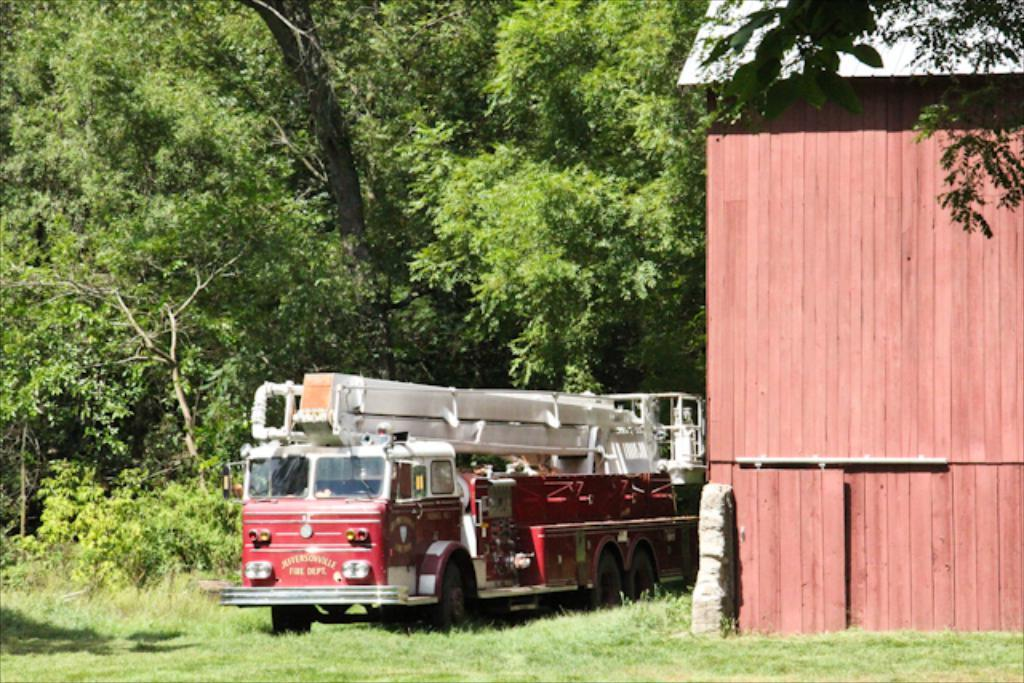What is the main subject of the image? The main subject of the image is a fire engine. What type of building can be seen in the image? There is a building with a wooden wall in the image. What is the ground covered with in the image? There is grass on the ground in the image. What can be seen in the background of the image? There are trees in the background of the image. What type of bottle is being used to surprise the fire engine in the image? There is no bottle or surprise element present in the image; it features a fire engine, a building with a wooden wall, grass on the ground, and trees in the background. 